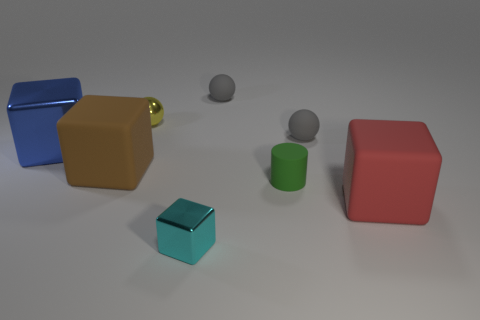What material is the cyan cube that is the same size as the yellow object?
Keep it short and to the point. Metal. Is the number of big blue shiny things less than the number of small purple rubber things?
Provide a succinct answer. No. There is a shiny object that is both to the right of the blue object and behind the tiny green cylinder; what size is it?
Provide a succinct answer. Small. There is a sphere left of the matte sphere behind the metallic object behind the blue thing; how big is it?
Give a very brief answer. Small. What number of other objects are there of the same color as the small cylinder?
Offer a terse response. 0. What number of objects are small brown objects or big brown rubber objects?
Ensure brevity in your answer.  1. What color is the metallic ball behind the blue thing?
Keep it short and to the point. Yellow. Is the number of tiny yellow metallic things to the left of the blue cube less than the number of small spheres?
Give a very brief answer. Yes. Do the big brown cube and the red thing have the same material?
Your answer should be very brief. Yes. What number of things are either tiny metal objects that are behind the red rubber cube or shiny blocks that are in front of the big blue cube?
Offer a terse response. 2. 